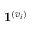Convert formula to latex. <formula><loc_0><loc_0><loc_500><loc_500>1 ^ { ( v _ { i } ) }</formula> 